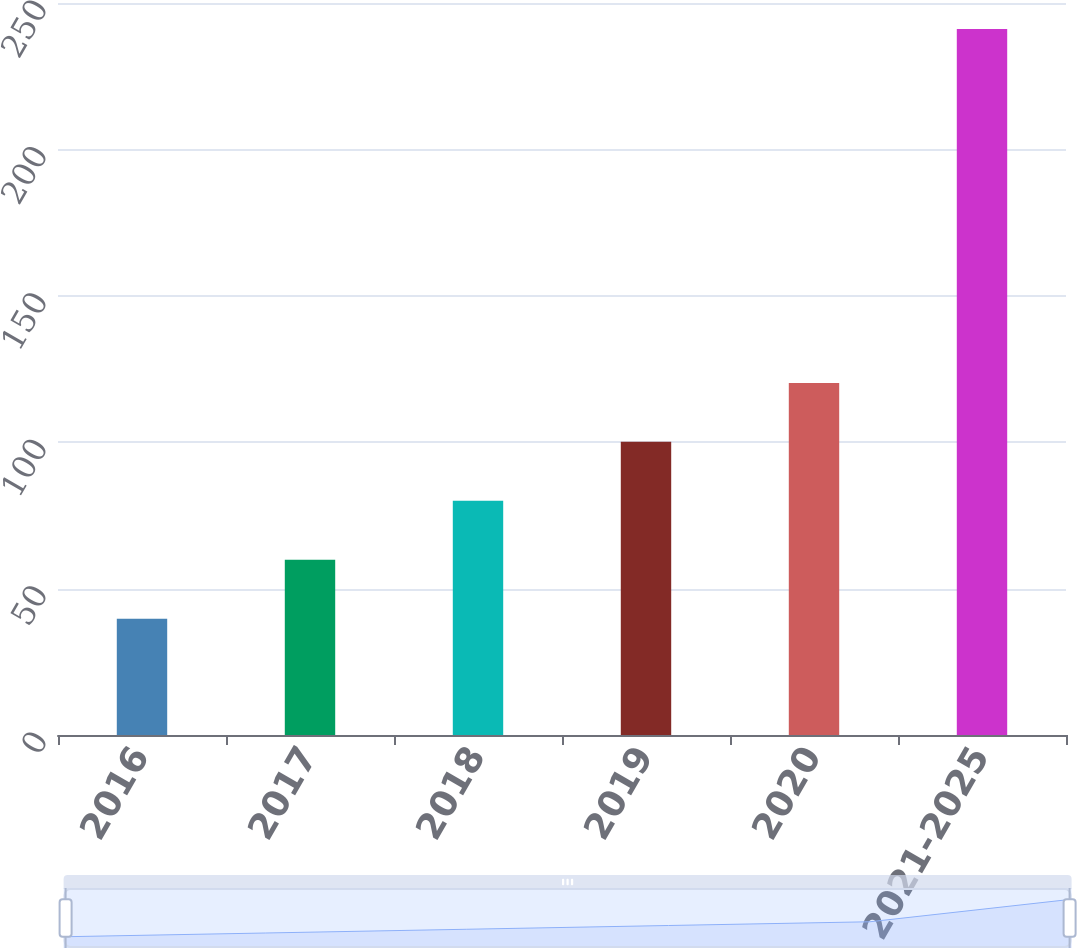<chart> <loc_0><loc_0><loc_500><loc_500><bar_chart><fcel>2016<fcel>2017<fcel>2018<fcel>2019<fcel>2020<fcel>2021-2025<nl><fcel>39.7<fcel>59.84<fcel>79.98<fcel>100.12<fcel>120.26<fcel>241.1<nl></chart> 